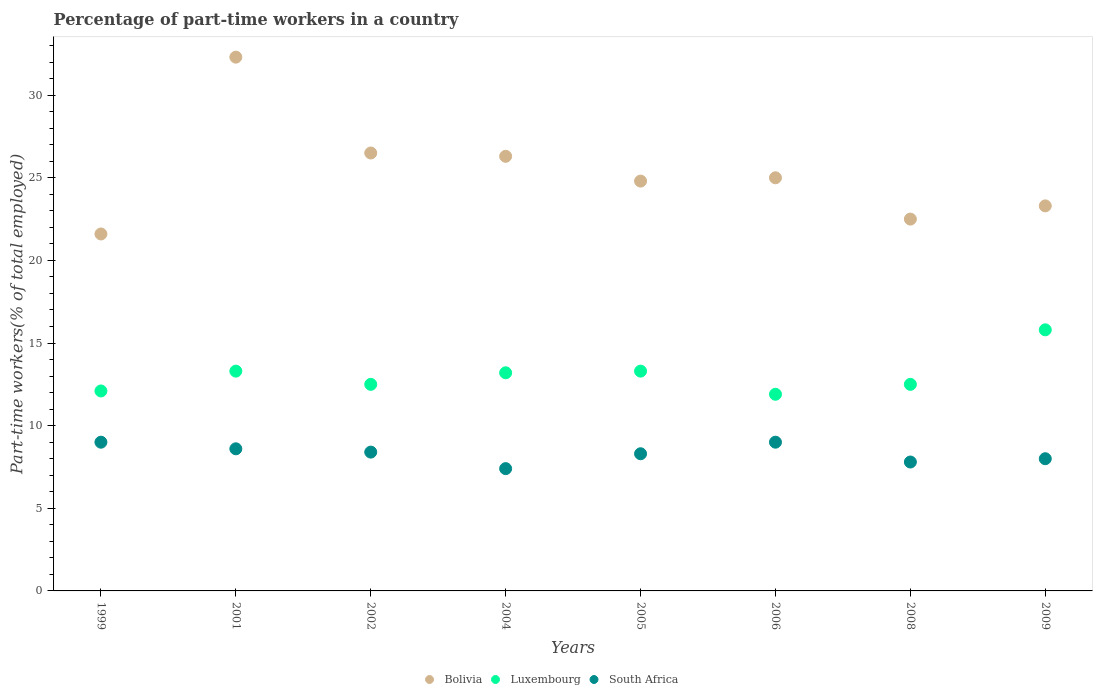How many different coloured dotlines are there?
Give a very brief answer. 3. Across all years, what is the maximum percentage of part-time workers in Luxembourg?
Provide a short and direct response. 15.8. Across all years, what is the minimum percentage of part-time workers in Bolivia?
Ensure brevity in your answer.  21.6. In which year was the percentage of part-time workers in Bolivia maximum?
Offer a very short reply. 2001. What is the total percentage of part-time workers in South Africa in the graph?
Offer a very short reply. 66.5. What is the difference between the percentage of part-time workers in South Africa in 1999 and that in 2006?
Give a very brief answer. 0. What is the average percentage of part-time workers in South Africa per year?
Provide a short and direct response. 8.31. In the year 2004, what is the difference between the percentage of part-time workers in Bolivia and percentage of part-time workers in South Africa?
Your answer should be compact. 18.9. What is the ratio of the percentage of part-time workers in Luxembourg in 2002 to that in 2004?
Ensure brevity in your answer.  0.95. What is the difference between the highest and the second highest percentage of part-time workers in Luxembourg?
Provide a succinct answer. 2.5. What is the difference between the highest and the lowest percentage of part-time workers in Bolivia?
Your answer should be very brief. 10.7. Is the sum of the percentage of part-time workers in Luxembourg in 2001 and 2005 greater than the maximum percentage of part-time workers in Bolivia across all years?
Your answer should be compact. No. Is it the case that in every year, the sum of the percentage of part-time workers in Bolivia and percentage of part-time workers in Luxembourg  is greater than the percentage of part-time workers in South Africa?
Your response must be concise. Yes. Does the percentage of part-time workers in Luxembourg monotonically increase over the years?
Keep it short and to the point. No. Is the percentage of part-time workers in Bolivia strictly greater than the percentage of part-time workers in South Africa over the years?
Offer a very short reply. Yes. Is the percentage of part-time workers in Luxembourg strictly less than the percentage of part-time workers in South Africa over the years?
Ensure brevity in your answer.  No. How many years are there in the graph?
Offer a very short reply. 8. What is the difference between two consecutive major ticks on the Y-axis?
Your answer should be compact. 5. Where does the legend appear in the graph?
Provide a short and direct response. Bottom center. How are the legend labels stacked?
Keep it short and to the point. Horizontal. What is the title of the graph?
Your response must be concise. Percentage of part-time workers in a country. Does "Rwanda" appear as one of the legend labels in the graph?
Provide a short and direct response. No. What is the label or title of the Y-axis?
Offer a very short reply. Part-time workers(% of total employed). What is the Part-time workers(% of total employed) of Bolivia in 1999?
Provide a succinct answer. 21.6. What is the Part-time workers(% of total employed) in Luxembourg in 1999?
Your response must be concise. 12.1. What is the Part-time workers(% of total employed) in South Africa in 1999?
Ensure brevity in your answer.  9. What is the Part-time workers(% of total employed) of Bolivia in 2001?
Keep it short and to the point. 32.3. What is the Part-time workers(% of total employed) in Luxembourg in 2001?
Offer a very short reply. 13.3. What is the Part-time workers(% of total employed) of South Africa in 2001?
Make the answer very short. 8.6. What is the Part-time workers(% of total employed) in Bolivia in 2002?
Your answer should be very brief. 26.5. What is the Part-time workers(% of total employed) in South Africa in 2002?
Your answer should be very brief. 8.4. What is the Part-time workers(% of total employed) of Bolivia in 2004?
Provide a succinct answer. 26.3. What is the Part-time workers(% of total employed) in Luxembourg in 2004?
Your answer should be compact. 13.2. What is the Part-time workers(% of total employed) in South Africa in 2004?
Your answer should be compact. 7.4. What is the Part-time workers(% of total employed) in Bolivia in 2005?
Your answer should be compact. 24.8. What is the Part-time workers(% of total employed) in Luxembourg in 2005?
Offer a very short reply. 13.3. What is the Part-time workers(% of total employed) in South Africa in 2005?
Your answer should be compact. 8.3. What is the Part-time workers(% of total employed) in Luxembourg in 2006?
Provide a short and direct response. 11.9. What is the Part-time workers(% of total employed) of South Africa in 2006?
Keep it short and to the point. 9. What is the Part-time workers(% of total employed) in South Africa in 2008?
Offer a very short reply. 7.8. What is the Part-time workers(% of total employed) in Bolivia in 2009?
Provide a succinct answer. 23.3. What is the Part-time workers(% of total employed) of Luxembourg in 2009?
Keep it short and to the point. 15.8. What is the Part-time workers(% of total employed) in South Africa in 2009?
Make the answer very short. 8. Across all years, what is the maximum Part-time workers(% of total employed) of Bolivia?
Provide a succinct answer. 32.3. Across all years, what is the maximum Part-time workers(% of total employed) in Luxembourg?
Ensure brevity in your answer.  15.8. Across all years, what is the maximum Part-time workers(% of total employed) in South Africa?
Provide a short and direct response. 9. Across all years, what is the minimum Part-time workers(% of total employed) of Bolivia?
Your answer should be very brief. 21.6. Across all years, what is the minimum Part-time workers(% of total employed) of Luxembourg?
Ensure brevity in your answer.  11.9. Across all years, what is the minimum Part-time workers(% of total employed) of South Africa?
Offer a terse response. 7.4. What is the total Part-time workers(% of total employed) of Bolivia in the graph?
Give a very brief answer. 202.3. What is the total Part-time workers(% of total employed) of Luxembourg in the graph?
Provide a short and direct response. 104.6. What is the total Part-time workers(% of total employed) in South Africa in the graph?
Offer a terse response. 66.5. What is the difference between the Part-time workers(% of total employed) in Bolivia in 1999 and that in 2001?
Provide a short and direct response. -10.7. What is the difference between the Part-time workers(% of total employed) in Luxembourg in 1999 and that in 2001?
Ensure brevity in your answer.  -1.2. What is the difference between the Part-time workers(% of total employed) in South Africa in 1999 and that in 2001?
Your answer should be very brief. 0.4. What is the difference between the Part-time workers(% of total employed) of Bolivia in 1999 and that in 2002?
Provide a short and direct response. -4.9. What is the difference between the Part-time workers(% of total employed) in Luxembourg in 1999 and that in 2002?
Keep it short and to the point. -0.4. What is the difference between the Part-time workers(% of total employed) in South Africa in 1999 and that in 2002?
Your answer should be very brief. 0.6. What is the difference between the Part-time workers(% of total employed) in South Africa in 1999 and that in 2004?
Provide a short and direct response. 1.6. What is the difference between the Part-time workers(% of total employed) of Bolivia in 1999 and that in 2005?
Ensure brevity in your answer.  -3.2. What is the difference between the Part-time workers(% of total employed) in Luxembourg in 1999 and that in 2005?
Your answer should be compact. -1.2. What is the difference between the Part-time workers(% of total employed) of South Africa in 1999 and that in 2005?
Keep it short and to the point. 0.7. What is the difference between the Part-time workers(% of total employed) in Bolivia in 1999 and that in 2006?
Ensure brevity in your answer.  -3.4. What is the difference between the Part-time workers(% of total employed) in Luxembourg in 1999 and that in 2006?
Give a very brief answer. 0.2. What is the difference between the Part-time workers(% of total employed) of South Africa in 1999 and that in 2006?
Offer a terse response. 0. What is the difference between the Part-time workers(% of total employed) of Bolivia in 1999 and that in 2008?
Ensure brevity in your answer.  -0.9. What is the difference between the Part-time workers(% of total employed) of Luxembourg in 1999 and that in 2009?
Keep it short and to the point. -3.7. What is the difference between the Part-time workers(% of total employed) of South Africa in 1999 and that in 2009?
Keep it short and to the point. 1. What is the difference between the Part-time workers(% of total employed) in Luxembourg in 2001 and that in 2002?
Your answer should be compact. 0.8. What is the difference between the Part-time workers(% of total employed) of South Africa in 2001 and that in 2002?
Keep it short and to the point. 0.2. What is the difference between the Part-time workers(% of total employed) in South Africa in 2001 and that in 2004?
Provide a succinct answer. 1.2. What is the difference between the Part-time workers(% of total employed) of Luxembourg in 2001 and that in 2005?
Your answer should be compact. 0. What is the difference between the Part-time workers(% of total employed) of South Africa in 2001 and that in 2006?
Offer a very short reply. -0.4. What is the difference between the Part-time workers(% of total employed) in Luxembourg in 2001 and that in 2008?
Give a very brief answer. 0.8. What is the difference between the Part-time workers(% of total employed) in South Africa in 2001 and that in 2008?
Your answer should be compact. 0.8. What is the difference between the Part-time workers(% of total employed) in Luxembourg in 2002 and that in 2004?
Your answer should be very brief. -0.7. What is the difference between the Part-time workers(% of total employed) in South Africa in 2002 and that in 2004?
Ensure brevity in your answer.  1. What is the difference between the Part-time workers(% of total employed) in South Africa in 2002 and that in 2005?
Keep it short and to the point. 0.1. What is the difference between the Part-time workers(% of total employed) in Luxembourg in 2002 and that in 2006?
Provide a short and direct response. 0.6. What is the difference between the Part-time workers(% of total employed) of Bolivia in 2002 and that in 2008?
Provide a succinct answer. 4. What is the difference between the Part-time workers(% of total employed) in Luxembourg in 2002 and that in 2008?
Provide a short and direct response. 0. What is the difference between the Part-time workers(% of total employed) of South Africa in 2002 and that in 2008?
Your answer should be very brief. 0.6. What is the difference between the Part-time workers(% of total employed) of Luxembourg in 2002 and that in 2009?
Ensure brevity in your answer.  -3.3. What is the difference between the Part-time workers(% of total employed) of Bolivia in 2004 and that in 2005?
Your response must be concise. 1.5. What is the difference between the Part-time workers(% of total employed) of Luxembourg in 2004 and that in 2005?
Your response must be concise. -0.1. What is the difference between the Part-time workers(% of total employed) of South Africa in 2004 and that in 2005?
Offer a terse response. -0.9. What is the difference between the Part-time workers(% of total employed) in Luxembourg in 2004 and that in 2006?
Your answer should be compact. 1.3. What is the difference between the Part-time workers(% of total employed) of Bolivia in 2004 and that in 2008?
Ensure brevity in your answer.  3.8. What is the difference between the Part-time workers(% of total employed) of South Africa in 2004 and that in 2008?
Give a very brief answer. -0.4. What is the difference between the Part-time workers(% of total employed) of Bolivia in 2004 and that in 2009?
Offer a terse response. 3. What is the difference between the Part-time workers(% of total employed) of Luxembourg in 2004 and that in 2009?
Provide a short and direct response. -2.6. What is the difference between the Part-time workers(% of total employed) of South Africa in 2004 and that in 2009?
Your answer should be very brief. -0.6. What is the difference between the Part-time workers(% of total employed) in Luxembourg in 2005 and that in 2008?
Keep it short and to the point. 0.8. What is the difference between the Part-time workers(% of total employed) of Bolivia in 2005 and that in 2009?
Your answer should be very brief. 1.5. What is the difference between the Part-time workers(% of total employed) of Luxembourg in 2005 and that in 2009?
Your response must be concise. -2.5. What is the difference between the Part-time workers(% of total employed) in Bolivia in 2006 and that in 2008?
Make the answer very short. 2.5. What is the difference between the Part-time workers(% of total employed) in South Africa in 2006 and that in 2009?
Keep it short and to the point. 1. What is the difference between the Part-time workers(% of total employed) in Bolivia in 2008 and that in 2009?
Provide a succinct answer. -0.8. What is the difference between the Part-time workers(% of total employed) in South Africa in 2008 and that in 2009?
Offer a terse response. -0.2. What is the difference between the Part-time workers(% of total employed) in Bolivia in 1999 and the Part-time workers(% of total employed) in Luxembourg in 2001?
Ensure brevity in your answer.  8.3. What is the difference between the Part-time workers(% of total employed) in Bolivia in 1999 and the Part-time workers(% of total employed) in South Africa in 2001?
Give a very brief answer. 13. What is the difference between the Part-time workers(% of total employed) of Bolivia in 1999 and the Part-time workers(% of total employed) of Luxembourg in 2002?
Provide a short and direct response. 9.1. What is the difference between the Part-time workers(% of total employed) in Bolivia in 1999 and the Part-time workers(% of total employed) in South Africa in 2002?
Keep it short and to the point. 13.2. What is the difference between the Part-time workers(% of total employed) in Luxembourg in 1999 and the Part-time workers(% of total employed) in South Africa in 2002?
Your answer should be compact. 3.7. What is the difference between the Part-time workers(% of total employed) in Luxembourg in 1999 and the Part-time workers(% of total employed) in South Africa in 2005?
Offer a very short reply. 3.8. What is the difference between the Part-time workers(% of total employed) of Bolivia in 1999 and the Part-time workers(% of total employed) of Luxembourg in 2006?
Give a very brief answer. 9.7. What is the difference between the Part-time workers(% of total employed) in Bolivia in 1999 and the Part-time workers(% of total employed) in South Africa in 2006?
Make the answer very short. 12.6. What is the difference between the Part-time workers(% of total employed) in Luxembourg in 1999 and the Part-time workers(% of total employed) in South Africa in 2006?
Your response must be concise. 3.1. What is the difference between the Part-time workers(% of total employed) in Bolivia in 1999 and the Part-time workers(% of total employed) in Luxembourg in 2008?
Your answer should be very brief. 9.1. What is the difference between the Part-time workers(% of total employed) in Bolivia in 1999 and the Part-time workers(% of total employed) in South Africa in 2008?
Provide a succinct answer. 13.8. What is the difference between the Part-time workers(% of total employed) of Bolivia in 2001 and the Part-time workers(% of total employed) of Luxembourg in 2002?
Make the answer very short. 19.8. What is the difference between the Part-time workers(% of total employed) in Bolivia in 2001 and the Part-time workers(% of total employed) in South Africa in 2002?
Keep it short and to the point. 23.9. What is the difference between the Part-time workers(% of total employed) in Bolivia in 2001 and the Part-time workers(% of total employed) in Luxembourg in 2004?
Provide a succinct answer. 19.1. What is the difference between the Part-time workers(% of total employed) in Bolivia in 2001 and the Part-time workers(% of total employed) in South Africa in 2004?
Make the answer very short. 24.9. What is the difference between the Part-time workers(% of total employed) of Luxembourg in 2001 and the Part-time workers(% of total employed) of South Africa in 2004?
Provide a succinct answer. 5.9. What is the difference between the Part-time workers(% of total employed) of Bolivia in 2001 and the Part-time workers(% of total employed) of South Africa in 2005?
Your answer should be compact. 24. What is the difference between the Part-time workers(% of total employed) of Luxembourg in 2001 and the Part-time workers(% of total employed) of South Africa in 2005?
Keep it short and to the point. 5. What is the difference between the Part-time workers(% of total employed) in Bolivia in 2001 and the Part-time workers(% of total employed) in Luxembourg in 2006?
Make the answer very short. 20.4. What is the difference between the Part-time workers(% of total employed) of Bolivia in 2001 and the Part-time workers(% of total employed) of South Africa in 2006?
Make the answer very short. 23.3. What is the difference between the Part-time workers(% of total employed) of Bolivia in 2001 and the Part-time workers(% of total employed) of Luxembourg in 2008?
Your response must be concise. 19.8. What is the difference between the Part-time workers(% of total employed) in Bolivia in 2001 and the Part-time workers(% of total employed) in South Africa in 2008?
Provide a succinct answer. 24.5. What is the difference between the Part-time workers(% of total employed) of Luxembourg in 2001 and the Part-time workers(% of total employed) of South Africa in 2008?
Your answer should be compact. 5.5. What is the difference between the Part-time workers(% of total employed) in Bolivia in 2001 and the Part-time workers(% of total employed) in South Africa in 2009?
Your answer should be very brief. 24.3. What is the difference between the Part-time workers(% of total employed) in Bolivia in 2002 and the Part-time workers(% of total employed) in South Africa in 2004?
Your response must be concise. 19.1. What is the difference between the Part-time workers(% of total employed) of Luxembourg in 2002 and the Part-time workers(% of total employed) of South Africa in 2004?
Keep it short and to the point. 5.1. What is the difference between the Part-time workers(% of total employed) in Bolivia in 2002 and the Part-time workers(% of total employed) in South Africa in 2005?
Provide a succinct answer. 18.2. What is the difference between the Part-time workers(% of total employed) in Luxembourg in 2002 and the Part-time workers(% of total employed) in South Africa in 2005?
Make the answer very short. 4.2. What is the difference between the Part-time workers(% of total employed) of Bolivia in 2002 and the Part-time workers(% of total employed) of Luxembourg in 2006?
Keep it short and to the point. 14.6. What is the difference between the Part-time workers(% of total employed) in Bolivia in 2002 and the Part-time workers(% of total employed) in South Africa in 2006?
Make the answer very short. 17.5. What is the difference between the Part-time workers(% of total employed) of Luxembourg in 2002 and the Part-time workers(% of total employed) of South Africa in 2006?
Provide a short and direct response. 3.5. What is the difference between the Part-time workers(% of total employed) in Bolivia in 2002 and the Part-time workers(% of total employed) in Luxembourg in 2009?
Your answer should be very brief. 10.7. What is the difference between the Part-time workers(% of total employed) in Bolivia in 2002 and the Part-time workers(% of total employed) in South Africa in 2009?
Your answer should be very brief. 18.5. What is the difference between the Part-time workers(% of total employed) in Luxembourg in 2004 and the Part-time workers(% of total employed) in South Africa in 2005?
Give a very brief answer. 4.9. What is the difference between the Part-time workers(% of total employed) of Luxembourg in 2004 and the Part-time workers(% of total employed) of South Africa in 2008?
Offer a terse response. 5.4. What is the difference between the Part-time workers(% of total employed) of Bolivia in 2004 and the Part-time workers(% of total employed) of Luxembourg in 2009?
Your answer should be very brief. 10.5. What is the difference between the Part-time workers(% of total employed) of Luxembourg in 2005 and the Part-time workers(% of total employed) of South Africa in 2006?
Keep it short and to the point. 4.3. What is the difference between the Part-time workers(% of total employed) of Luxembourg in 2005 and the Part-time workers(% of total employed) of South Africa in 2008?
Offer a very short reply. 5.5. What is the difference between the Part-time workers(% of total employed) of Bolivia in 2005 and the Part-time workers(% of total employed) of Luxembourg in 2009?
Your response must be concise. 9. What is the difference between the Part-time workers(% of total employed) in Luxembourg in 2005 and the Part-time workers(% of total employed) in South Africa in 2009?
Your response must be concise. 5.3. What is the difference between the Part-time workers(% of total employed) in Bolivia in 2006 and the Part-time workers(% of total employed) in South Africa in 2008?
Offer a terse response. 17.2. What is the difference between the Part-time workers(% of total employed) of Luxembourg in 2006 and the Part-time workers(% of total employed) of South Africa in 2008?
Give a very brief answer. 4.1. What is the difference between the Part-time workers(% of total employed) in Bolivia in 2006 and the Part-time workers(% of total employed) in Luxembourg in 2009?
Your answer should be compact. 9.2. What is the difference between the Part-time workers(% of total employed) of Bolivia in 2006 and the Part-time workers(% of total employed) of South Africa in 2009?
Your answer should be very brief. 17. What is the difference between the Part-time workers(% of total employed) of Luxembourg in 2006 and the Part-time workers(% of total employed) of South Africa in 2009?
Your answer should be very brief. 3.9. What is the difference between the Part-time workers(% of total employed) of Bolivia in 2008 and the Part-time workers(% of total employed) of South Africa in 2009?
Provide a short and direct response. 14.5. What is the difference between the Part-time workers(% of total employed) in Luxembourg in 2008 and the Part-time workers(% of total employed) in South Africa in 2009?
Give a very brief answer. 4.5. What is the average Part-time workers(% of total employed) in Bolivia per year?
Keep it short and to the point. 25.29. What is the average Part-time workers(% of total employed) in Luxembourg per year?
Offer a terse response. 13.07. What is the average Part-time workers(% of total employed) of South Africa per year?
Offer a terse response. 8.31. In the year 1999, what is the difference between the Part-time workers(% of total employed) in Bolivia and Part-time workers(% of total employed) in Luxembourg?
Make the answer very short. 9.5. In the year 2001, what is the difference between the Part-time workers(% of total employed) in Bolivia and Part-time workers(% of total employed) in Luxembourg?
Keep it short and to the point. 19. In the year 2001, what is the difference between the Part-time workers(% of total employed) of Bolivia and Part-time workers(% of total employed) of South Africa?
Your response must be concise. 23.7. In the year 2001, what is the difference between the Part-time workers(% of total employed) in Luxembourg and Part-time workers(% of total employed) in South Africa?
Keep it short and to the point. 4.7. In the year 2002, what is the difference between the Part-time workers(% of total employed) of Bolivia and Part-time workers(% of total employed) of Luxembourg?
Make the answer very short. 14. In the year 2002, what is the difference between the Part-time workers(% of total employed) in Bolivia and Part-time workers(% of total employed) in South Africa?
Your answer should be compact. 18.1. In the year 2002, what is the difference between the Part-time workers(% of total employed) in Luxembourg and Part-time workers(% of total employed) in South Africa?
Your response must be concise. 4.1. In the year 2004, what is the difference between the Part-time workers(% of total employed) in Bolivia and Part-time workers(% of total employed) in South Africa?
Offer a very short reply. 18.9. In the year 2005, what is the difference between the Part-time workers(% of total employed) in Bolivia and Part-time workers(% of total employed) in Luxembourg?
Your answer should be very brief. 11.5. In the year 2005, what is the difference between the Part-time workers(% of total employed) in Luxembourg and Part-time workers(% of total employed) in South Africa?
Your answer should be compact. 5. In the year 2008, what is the difference between the Part-time workers(% of total employed) in Bolivia and Part-time workers(% of total employed) in South Africa?
Your answer should be compact. 14.7. In the year 2009, what is the difference between the Part-time workers(% of total employed) of Bolivia and Part-time workers(% of total employed) of Luxembourg?
Your answer should be compact. 7.5. What is the ratio of the Part-time workers(% of total employed) of Bolivia in 1999 to that in 2001?
Your answer should be very brief. 0.67. What is the ratio of the Part-time workers(% of total employed) of Luxembourg in 1999 to that in 2001?
Your answer should be very brief. 0.91. What is the ratio of the Part-time workers(% of total employed) of South Africa in 1999 to that in 2001?
Offer a very short reply. 1.05. What is the ratio of the Part-time workers(% of total employed) of Bolivia in 1999 to that in 2002?
Give a very brief answer. 0.82. What is the ratio of the Part-time workers(% of total employed) in South Africa in 1999 to that in 2002?
Ensure brevity in your answer.  1.07. What is the ratio of the Part-time workers(% of total employed) in Bolivia in 1999 to that in 2004?
Ensure brevity in your answer.  0.82. What is the ratio of the Part-time workers(% of total employed) in Luxembourg in 1999 to that in 2004?
Ensure brevity in your answer.  0.92. What is the ratio of the Part-time workers(% of total employed) in South Africa in 1999 to that in 2004?
Keep it short and to the point. 1.22. What is the ratio of the Part-time workers(% of total employed) in Bolivia in 1999 to that in 2005?
Provide a short and direct response. 0.87. What is the ratio of the Part-time workers(% of total employed) of Luxembourg in 1999 to that in 2005?
Your answer should be very brief. 0.91. What is the ratio of the Part-time workers(% of total employed) in South Africa in 1999 to that in 2005?
Provide a succinct answer. 1.08. What is the ratio of the Part-time workers(% of total employed) of Bolivia in 1999 to that in 2006?
Offer a very short reply. 0.86. What is the ratio of the Part-time workers(% of total employed) of Luxembourg in 1999 to that in 2006?
Provide a succinct answer. 1.02. What is the ratio of the Part-time workers(% of total employed) of South Africa in 1999 to that in 2006?
Keep it short and to the point. 1. What is the ratio of the Part-time workers(% of total employed) in Luxembourg in 1999 to that in 2008?
Keep it short and to the point. 0.97. What is the ratio of the Part-time workers(% of total employed) of South Africa in 1999 to that in 2008?
Your answer should be compact. 1.15. What is the ratio of the Part-time workers(% of total employed) of Bolivia in 1999 to that in 2009?
Make the answer very short. 0.93. What is the ratio of the Part-time workers(% of total employed) of Luxembourg in 1999 to that in 2009?
Give a very brief answer. 0.77. What is the ratio of the Part-time workers(% of total employed) in South Africa in 1999 to that in 2009?
Your answer should be very brief. 1.12. What is the ratio of the Part-time workers(% of total employed) in Bolivia in 2001 to that in 2002?
Your response must be concise. 1.22. What is the ratio of the Part-time workers(% of total employed) of Luxembourg in 2001 to that in 2002?
Provide a short and direct response. 1.06. What is the ratio of the Part-time workers(% of total employed) of South Africa in 2001 to that in 2002?
Offer a very short reply. 1.02. What is the ratio of the Part-time workers(% of total employed) of Bolivia in 2001 to that in 2004?
Provide a succinct answer. 1.23. What is the ratio of the Part-time workers(% of total employed) in Luxembourg in 2001 to that in 2004?
Make the answer very short. 1.01. What is the ratio of the Part-time workers(% of total employed) in South Africa in 2001 to that in 2004?
Your answer should be very brief. 1.16. What is the ratio of the Part-time workers(% of total employed) in Bolivia in 2001 to that in 2005?
Your response must be concise. 1.3. What is the ratio of the Part-time workers(% of total employed) of South Africa in 2001 to that in 2005?
Offer a terse response. 1.04. What is the ratio of the Part-time workers(% of total employed) in Bolivia in 2001 to that in 2006?
Your response must be concise. 1.29. What is the ratio of the Part-time workers(% of total employed) of Luxembourg in 2001 to that in 2006?
Offer a very short reply. 1.12. What is the ratio of the Part-time workers(% of total employed) in South Africa in 2001 to that in 2006?
Provide a succinct answer. 0.96. What is the ratio of the Part-time workers(% of total employed) in Bolivia in 2001 to that in 2008?
Provide a short and direct response. 1.44. What is the ratio of the Part-time workers(% of total employed) in Luxembourg in 2001 to that in 2008?
Provide a succinct answer. 1.06. What is the ratio of the Part-time workers(% of total employed) of South Africa in 2001 to that in 2008?
Provide a succinct answer. 1.1. What is the ratio of the Part-time workers(% of total employed) in Bolivia in 2001 to that in 2009?
Your response must be concise. 1.39. What is the ratio of the Part-time workers(% of total employed) in Luxembourg in 2001 to that in 2009?
Offer a terse response. 0.84. What is the ratio of the Part-time workers(% of total employed) of South Africa in 2001 to that in 2009?
Ensure brevity in your answer.  1.07. What is the ratio of the Part-time workers(% of total employed) of Bolivia in 2002 to that in 2004?
Your response must be concise. 1.01. What is the ratio of the Part-time workers(% of total employed) of Luxembourg in 2002 to that in 2004?
Your answer should be very brief. 0.95. What is the ratio of the Part-time workers(% of total employed) of South Africa in 2002 to that in 2004?
Give a very brief answer. 1.14. What is the ratio of the Part-time workers(% of total employed) in Bolivia in 2002 to that in 2005?
Make the answer very short. 1.07. What is the ratio of the Part-time workers(% of total employed) of Luxembourg in 2002 to that in 2005?
Your response must be concise. 0.94. What is the ratio of the Part-time workers(% of total employed) of Bolivia in 2002 to that in 2006?
Keep it short and to the point. 1.06. What is the ratio of the Part-time workers(% of total employed) in Luxembourg in 2002 to that in 2006?
Offer a terse response. 1.05. What is the ratio of the Part-time workers(% of total employed) of Bolivia in 2002 to that in 2008?
Keep it short and to the point. 1.18. What is the ratio of the Part-time workers(% of total employed) in Luxembourg in 2002 to that in 2008?
Make the answer very short. 1. What is the ratio of the Part-time workers(% of total employed) in South Africa in 2002 to that in 2008?
Your answer should be compact. 1.08. What is the ratio of the Part-time workers(% of total employed) in Bolivia in 2002 to that in 2009?
Your answer should be compact. 1.14. What is the ratio of the Part-time workers(% of total employed) in Luxembourg in 2002 to that in 2009?
Your answer should be very brief. 0.79. What is the ratio of the Part-time workers(% of total employed) of Bolivia in 2004 to that in 2005?
Your response must be concise. 1.06. What is the ratio of the Part-time workers(% of total employed) in South Africa in 2004 to that in 2005?
Provide a succinct answer. 0.89. What is the ratio of the Part-time workers(% of total employed) of Bolivia in 2004 to that in 2006?
Ensure brevity in your answer.  1.05. What is the ratio of the Part-time workers(% of total employed) of Luxembourg in 2004 to that in 2006?
Give a very brief answer. 1.11. What is the ratio of the Part-time workers(% of total employed) of South Africa in 2004 to that in 2006?
Your answer should be compact. 0.82. What is the ratio of the Part-time workers(% of total employed) of Bolivia in 2004 to that in 2008?
Keep it short and to the point. 1.17. What is the ratio of the Part-time workers(% of total employed) of Luxembourg in 2004 to that in 2008?
Provide a short and direct response. 1.06. What is the ratio of the Part-time workers(% of total employed) of South Africa in 2004 to that in 2008?
Ensure brevity in your answer.  0.95. What is the ratio of the Part-time workers(% of total employed) in Bolivia in 2004 to that in 2009?
Your answer should be very brief. 1.13. What is the ratio of the Part-time workers(% of total employed) of Luxembourg in 2004 to that in 2009?
Ensure brevity in your answer.  0.84. What is the ratio of the Part-time workers(% of total employed) in South Africa in 2004 to that in 2009?
Provide a succinct answer. 0.93. What is the ratio of the Part-time workers(% of total employed) in Luxembourg in 2005 to that in 2006?
Give a very brief answer. 1.12. What is the ratio of the Part-time workers(% of total employed) in South Africa in 2005 to that in 2006?
Offer a very short reply. 0.92. What is the ratio of the Part-time workers(% of total employed) of Bolivia in 2005 to that in 2008?
Give a very brief answer. 1.1. What is the ratio of the Part-time workers(% of total employed) of Luxembourg in 2005 to that in 2008?
Offer a very short reply. 1.06. What is the ratio of the Part-time workers(% of total employed) in South Africa in 2005 to that in 2008?
Provide a short and direct response. 1.06. What is the ratio of the Part-time workers(% of total employed) of Bolivia in 2005 to that in 2009?
Your answer should be compact. 1.06. What is the ratio of the Part-time workers(% of total employed) in Luxembourg in 2005 to that in 2009?
Your answer should be very brief. 0.84. What is the ratio of the Part-time workers(% of total employed) in South Africa in 2005 to that in 2009?
Provide a succinct answer. 1.04. What is the ratio of the Part-time workers(% of total employed) in South Africa in 2006 to that in 2008?
Ensure brevity in your answer.  1.15. What is the ratio of the Part-time workers(% of total employed) of Bolivia in 2006 to that in 2009?
Provide a short and direct response. 1.07. What is the ratio of the Part-time workers(% of total employed) of Luxembourg in 2006 to that in 2009?
Provide a succinct answer. 0.75. What is the ratio of the Part-time workers(% of total employed) of Bolivia in 2008 to that in 2009?
Your answer should be compact. 0.97. What is the ratio of the Part-time workers(% of total employed) of Luxembourg in 2008 to that in 2009?
Your response must be concise. 0.79. What is the difference between the highest and the second highest Part-time workers(% of total employed) in South Africa?
Offer a terse response. 0. What is the difference between the highest and the lowest Part-time workers(% of total employed) in Luxembourg?
Offer a very short reply. 3.9. What is the difference between the highest and the lowest Part-time workers(% of total employed) in South Africa?
Keep it short and to the point. 1.6. 